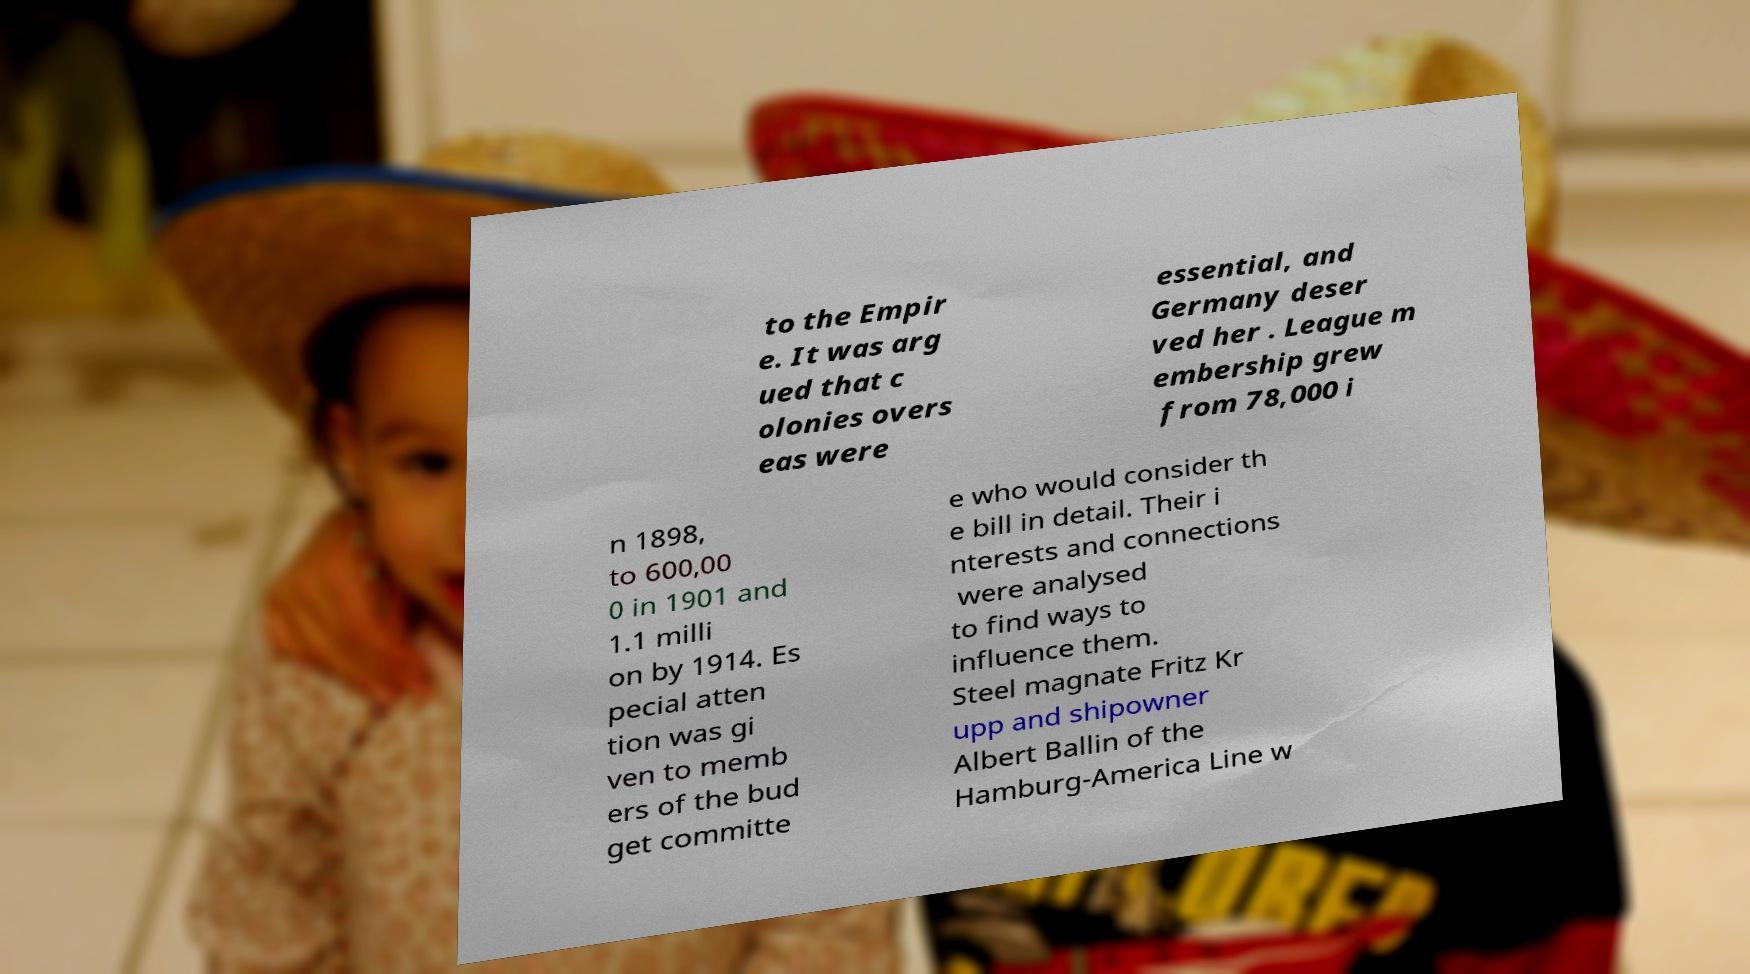Could you assist in decoding the text presented in this image and type it out clearly? to the Empir e. It was arg ued that c olonies overs eas were essential, and Germany deser ved her . League m embership grew from 78,000 i n 1898, to 600,00 0 in 1901 and 1.1 milli on by 1914. Es pecial atten tion was gi ven to memb ers of the bud get committe e who would consider th e bill in detail. Their i nterests and connections were analysed to find ways to influence them. Steel magnate Fritz Kr upp and shipowner Albert Ballin of the Hamburg-America Line w 